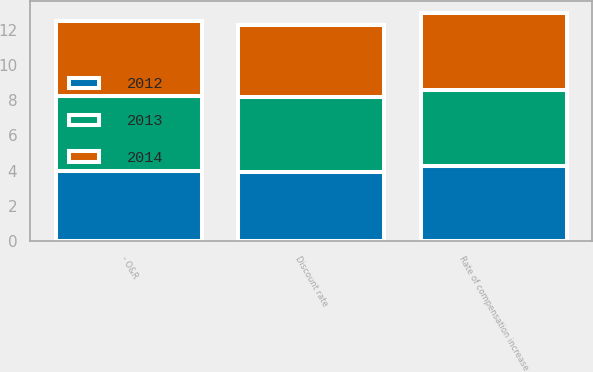<chart> <loc_0><loc_0><loc_500><loc_500><stacked_bar_chart><ecel><fcel>Discount rate<fcel>Rate of compensation increase<fcel>- O&R<nl><fcel>2012<fcel>3.9<fcel>4.25<fcel>4<nl><fcel>2013<fcel>4.25<fcel>4.35<fcel>4.25<nl><fcel>2014<fcel>4.1<fcel>4.35<fcel>4.25<nl></chart> 